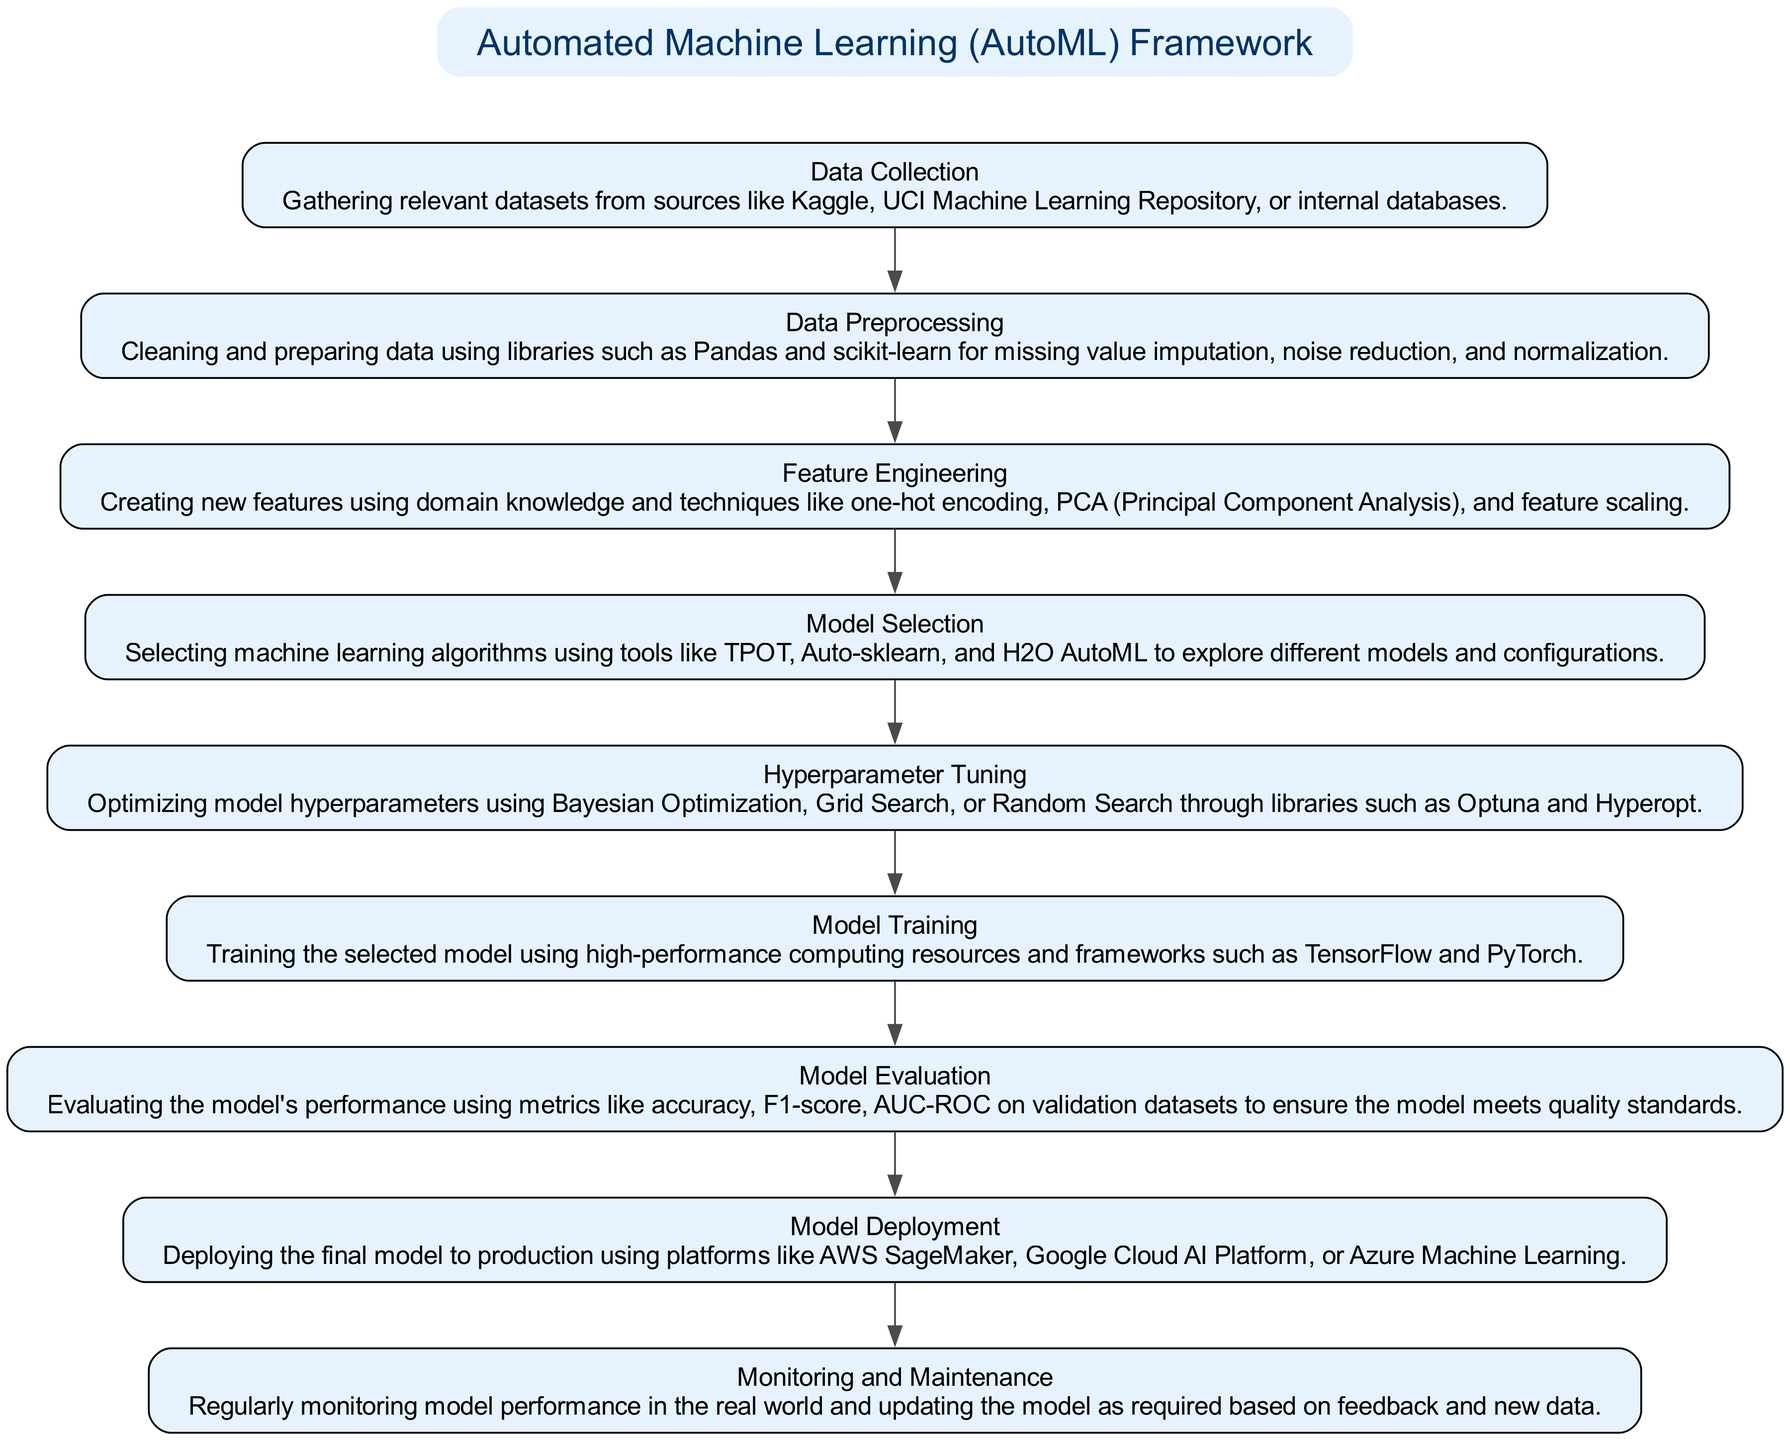What is the first step in the AutoML framework? The first step listed in the diagram is "Data Collection". It is shown as the first node after the title, indicating the starting point of the entire process.
Answer: Data Collection How many steps are there in total? By counting the nodes associated with the steps in the diagram, there are a total of nine steps listed, which can be confirmed visually.
Answer: Nine What is the output of the "Model Evaluation" step? The "Model Evaluation" step is evaluated using metrics like accuracy, F1-score, AUC-ROC, which are listed in the description. Thus, the outputs are various performance metrics for the evaluated model.
Answer: Performance metrics Which step comes after "Hyperparameter Tuning"? Based on the arrows connecting the steps in the diagram, "Model Training" is the subsequent step that follows "Hyperparameter Tuning".
Answer: Model Training What tools are mentioned for "Model Selection"? In the description of the "Model Selection" step, specific tools like TPOT, Auto-sklearn, and H2O AutoML are highlighted. These tools are explicitly mentioned as options for exploring different models.
Answer: TPOT, Auto-sklearn, H2O AutoML What are the two purposes of the "Monitoring and Maintenance" step? The description for "Monitoring and Maintenance" specifies that it involves regular monitoring of model performance in the real world and updates based on feedback and new data, constituting mainly performance observation and model refreshing.
Answer: Performance observation and model refreshing Name a library used in "Hyperparameter Tuning". The diagram mentions libraries like Optuna and Hyperopt for hyperparameter tuning. Optuna is one example explicitly referenced in the description of that step.
Answer: Optuna What is required during "Model Deployment"? In the "Model Deployment" step, it is necessary to utilize production platforms such as AWS SageMaker, Google Cloud AI Platform, or Azure Machine Learning as highlighted in the description for deploying the final model.
Answer: Production platforms What process follows "Model Training" in the flowchart? The flowchart indicates that after "Model Training", the next logical step is "Model Evaluation", which assesses how well the trained model performs.
Answer: Model Evaluation 